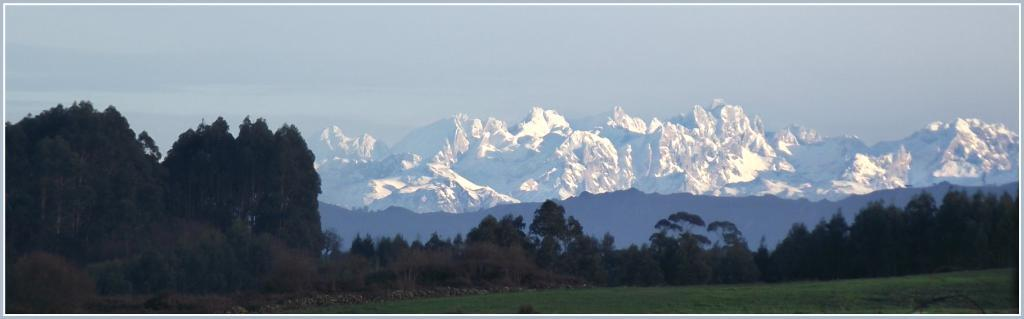What type of vegetation is present in the image? There are trees in the image. What other natural elements can be seen in the image? There are stones and grass visible in the image. What type of geographical feature is present in the background of the image? There are mountains in the image, some of which are covered with snow. What is visible in the sky in the image? The sky is visible in the image. Can you see any salt on the stones in the image? There is no salt visible on the stones in the image. Is there a chess game being played on the grass in the image? There is no chess game present in the image. 